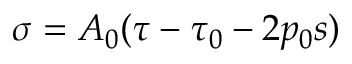Convert formula to latex. <formula><loc_0><loc_0><loc_500><loc_500>\sigma = A _ { 0 } ( \tau - \tau _ { 0 } - 2 p _ { 0 } s )</formula> 